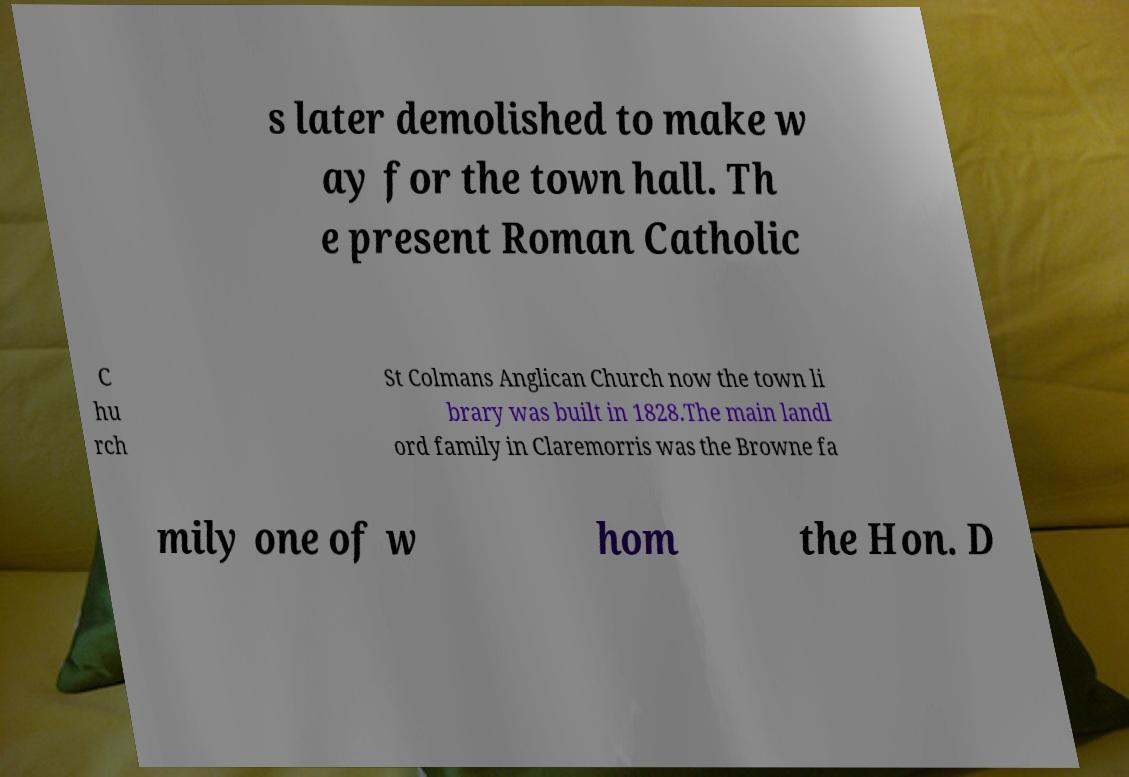Could you extract and type out the text from this image? s later demolished to make w ay for the town hall. Th e present Roman Catholic C hu rch St Colmans Anglican Church now the town li brary was built in 1828.The main landl ord family in Claremorris was the Browne fa mily one of w hom the Hon. D 